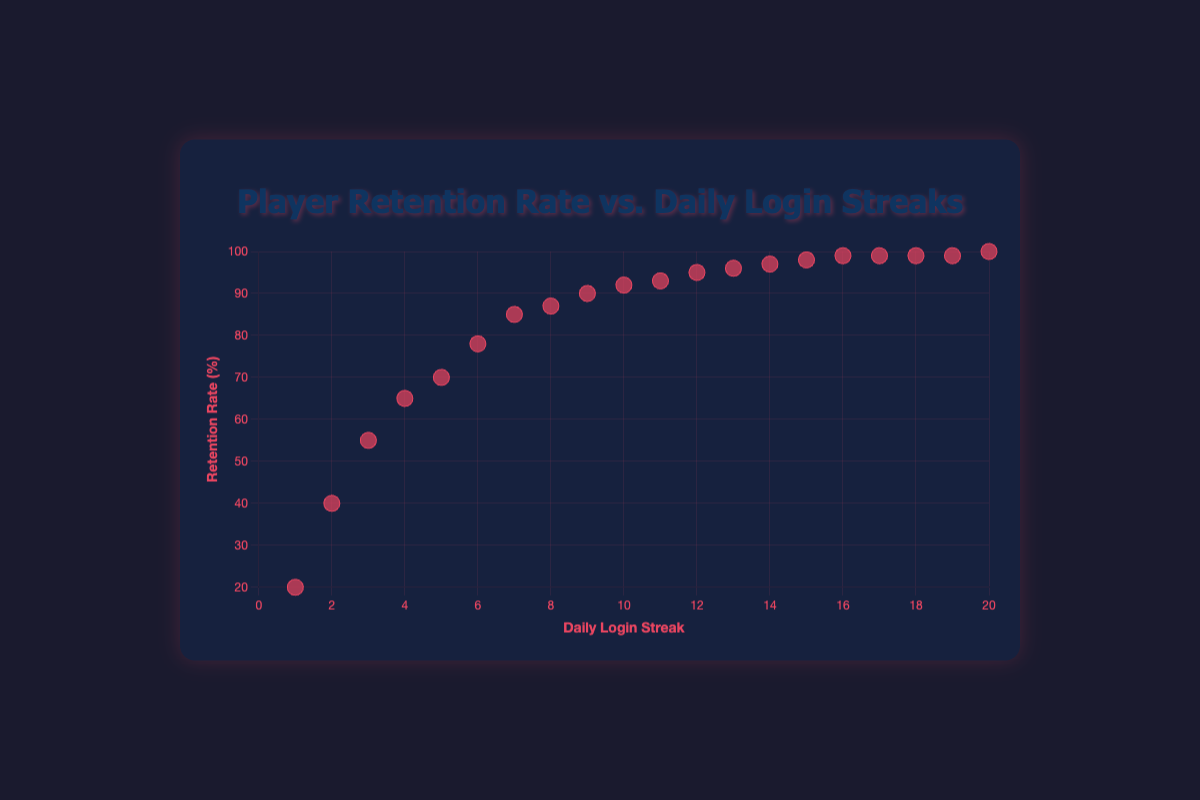What's the title of the scatter plot? The title of the scatter plot is displayed at the top of the figure. It reads "Player Retention Rate vs. Daily Login Streaks".
Answer: Player Retention Rate vs. Daily Login Streaks What values are represented on the x-axis? The x-axis of the scatter plot represents the daily login streaks of players. The x-axis title is "Daily Login Streak" and the axis is marked with numbers indicating streak lengths from 1 to 20.
Answer: Daily Login Streaks What's the retention rate for a player with a daily login streak of 10? Locate the point corresponding to a daily login streak of 10 on the x-axis and check its alignment with the y-axis. The point for a streak of 10 aligns with a retention rate of 92%.
Answer: 92% How many players have a daily login streak of more than 15 days? Count the number of points to the right of the x-axis value of 15. There are 5 points for players with daily login streaks of more than 15 days.
Answer: 5 Which player has the highest retention rate, and what is their daily login streak? Identify the highest point in terms of the y-axis value on the scatter plot, which represents retention rate. The highest retention rate is 100%, corresponding to the player Tina with a daily login streak of 20.
Answer: Tina, 20 Does the player retention rate tend to increase with the daily login streak? Examine the overall trend of the points on the scatter plot. Points rise on the y-axis as they move to the right on the x-axis, indicating that the retention rate increases with the daily login streak.
Answer: Yes What is the increase in retention rate from a daily login streak of 5 to a streak of 10? Find the retention rates for daily login streaks of 5 and 10 (70% and 92%, respectively). Calculate the difference: 92% - 70% = 22%.
Answer: 22% Compare the retention rates for players with a daily login streak of 6 and 8. Which is higher? Check the y-axis values for daily login streaks of 6 (78%) and 8 (87%). The retention rate for a streak of 8 is higher.
Answer: 8 is higher If a player has a retention rate of 99%, what could be their possible daily login streaks? Identify all points with a retention rate of 99% and note their x-axis values. Streaks for 99% retention rate appear at 16, 17, 18, and 19 days.
Answer: 16, 17, 18, 19 How does the trend of the scatter plot suggest improvements in player retention? The upward trend of points from left to right indicates that as players log in more frequently over consecutive days, their retention rate improves, suggesting that encouraging daily logins could improve player retention.
Answer: Increases with logins 